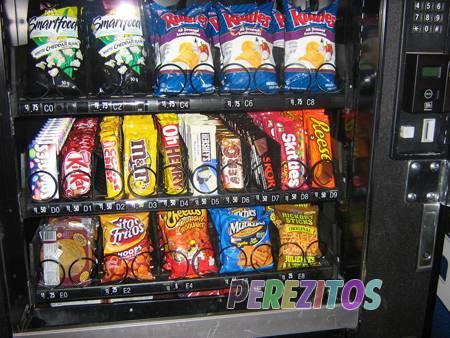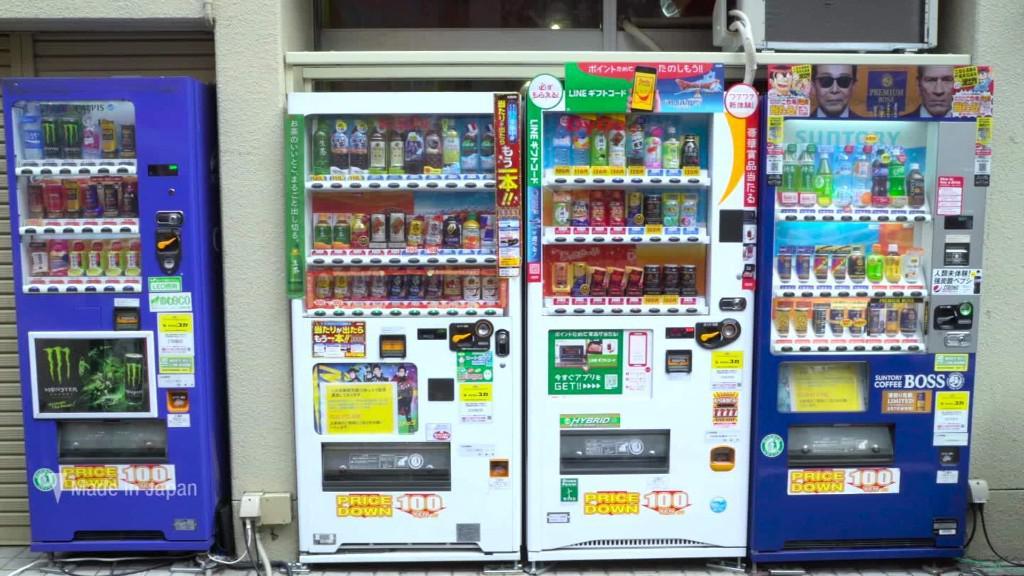The first image is the image on the left, the second image is the image on the right. For the images shown, is this caption "The right image shows a row of at least four vending machines." true? Answer yes or no. Yes. The first image is the image on the left, the second image is the image on the right. Analyze the images presented: Is the assertion "There is a row of red, white, and blue vending machines with pavement in front of them." valid? Answer yes or no. No. The first image is the image on the left, the second image is the image on the right. For the images shown, is this caption "There are no more than five machines." true? Answer yes or no. Yes. 